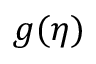<formula> <loc_0><loc_0><loc_500><loc_500>g ( \eta )</formula> 